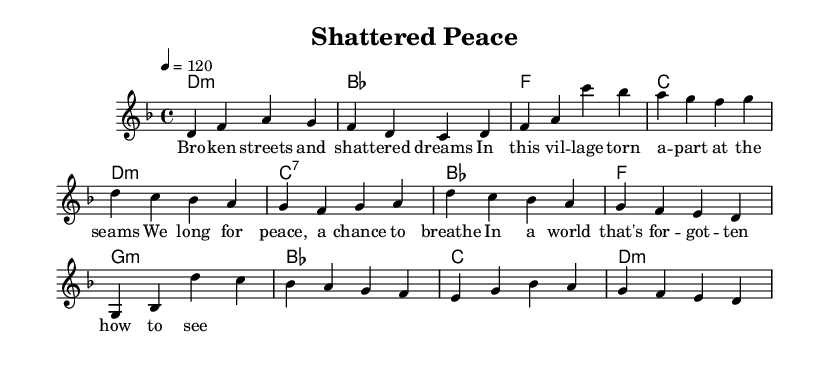What is the key signature of this music? The key signature is indicated at the beginning of the staff, showing two flats, which correspond to B flat and E flat. Therefore, it is in D minor.
Answer: D minor What is the time signature of this piece? The time signature is represented at the beginning of the music, showing a 4 over 4, which means there are four beats per measure and the quarter note gets one beat.
Answer: 4/4 What is the tempo marking of this music? The tempo marking at the beginning states "4 = 120," indicating that there are 120 beats per minute, with the fourth note receiving one beat.
Answer: 120 How many measures are in the verses and chorus combined? By counting the measures from the melody, the verse contains two measures, and the chorus contains another two measures, making a total of four measures combined.
Answer: 4 What is the primary theme expressed in the lyrics? The lyrics discuss the destruction and longing for peace in a war-torn village, revealing themes of hope amidst brokenness.
Answer: Longing for peace What type of chords are used in the harmony section? The chord symbols show a combination of minor and major chords, indicating a melancholic but hopeful sound typical of punk ballads that reflect struggle.
Answer: Minor and major chords Which musical section includes a bridge? The bridge is distinctly noted in the labeled melody as separate from the verse and chorus, providing a contrasting musical segment that typically heightens emotional tension.
Answer: Bridge 